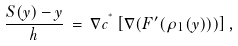Convert formula to latex. <formula><loc_0><loc_0><loc_500><loc_500>\frac { S ( y ) - y } { h } \, = \, \nabla c ^ { ^ { * } } \left [ \nabla ( F ^ { \prime } ( \rho _ { 1 } ( y ) ) ) \right ] ,</formula> 